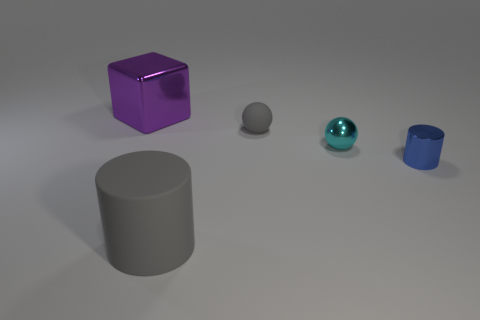Is the color of the cylinder that is in front of the blue cylinder the same as the rubber ball?
Provide a succinct answer. Yes. Is the color of the object that is in front of the tiny blue thing the same as the matte object behind the large gray thing?
Make the answer very short. Yes. The cylinder that is left of the rubber object behind the big thing in front of the big purple shiny object is made of what material?
Your answer should be very brief. Rubber. Is there a rubber ball of the same size as the blue metallic cylinder?
Keep it short and to the point. Yes. There is a purple object that is the same size as the gray cylinder; what material is it?
Keep it short and to the point. Metal. What shape is the big thing in front of the metal cylinder?
Your response must be concise. Cylinder. Is the material of the cylinder that is on the left side of the gray rubber sphere the same as the gray thing that is behind the tiny blue shiny cylinder?
Offer a very short reply. Yes. What number of other small matte objects are the same shape as the blue thing?
Offer a very short reply. 0. How many objects are tiny cyan metal balls or cylinders that are to the right of the matte cylinder?
Your answer should be compact. 2. What is the material of the purple thing?
Offer a very short reply. Metal. 